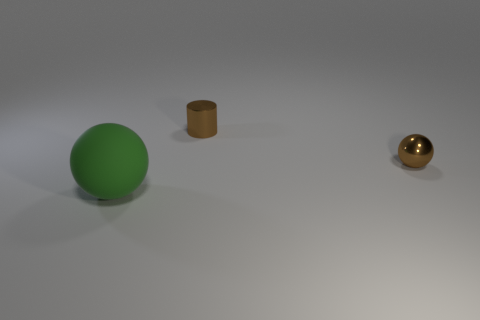Are there any other things that are the same size as the rubber sphere?
Your answer should be compact. No. Are there any other things that have the same material as the green sphere?
Provide a short and direct response. No. There is a object that is in front of the brown shiny cylinder and right of the green matte ball; what material is it?
Keep it short and to the point. Metal. The green ball has what size?
Your response must be concise. Large. The metallic thing that is the same shape as the green matte object is what color?
Your answer should be very brief. Brown. Is there any other thing of the same color as the matte object?
Provide a succinct answer. No. There is a brown metal object in front of the brown cylinder; does it have the same size as the thing that is left of the cylinder?
Ensure brevity in your answer.  No. Are there an equal number of small brown metallic cylinders behind the brown cylinder and spheres in front of the metallic ball?
Provide a short and direct response. No. There is a green rubber ball; is it the same size as the metal object left of the brown ball?
Offer a very short reply. No. There is a sphere on the right side of the green rubber ball; is there a small sphere behind it?
Your answer should be very brief. No. 